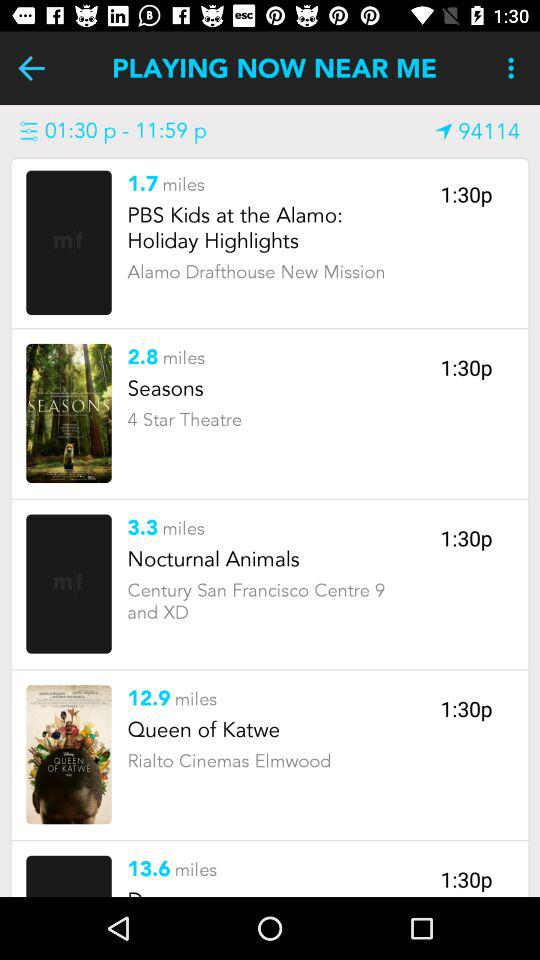How many miles away is "Queen of Katwe" playing? The "Queen of Katwe" is playing 12.9 miles away. 